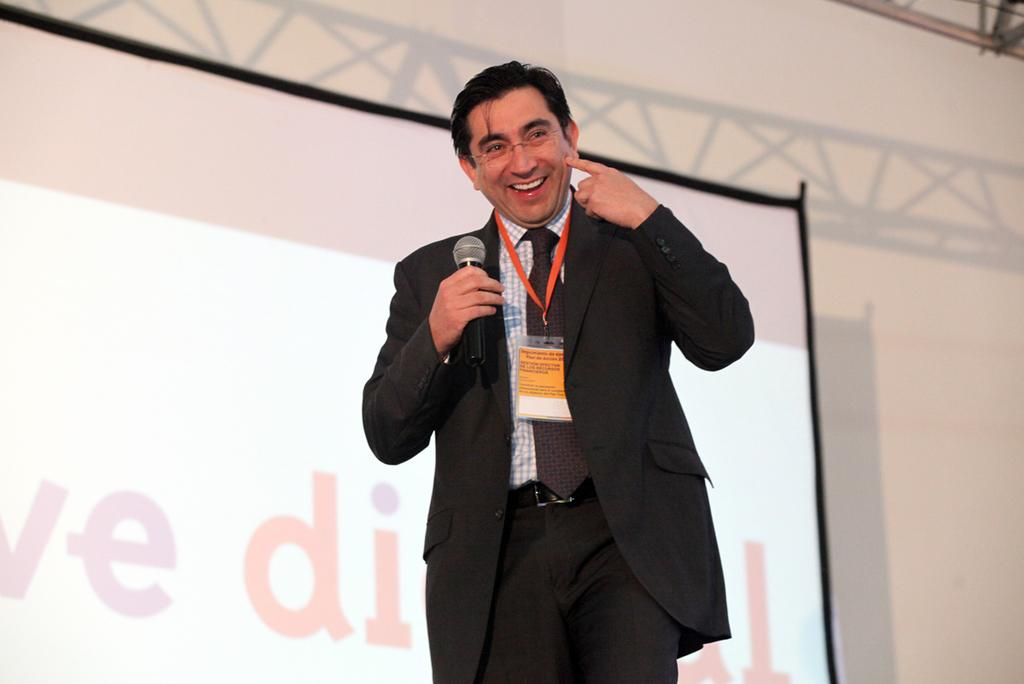What is the main subject of the image? There is a man standing in the center of the image. What is the man holding in the image? The man is holding a mic. What can be seen in the background of the image? There is a wall and a screen in the background of the image. How many ladybugs can be seen on the man's shoulder in the image? There are no ladybugs present in the image. What type of brass instrument is the man playing in the image? The man is not playing any brass instrument in the image; he is holding a mic. 